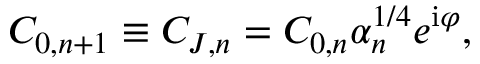<formula> <loc_0><loc_0><loc_500><loc_500>C _ { 0 , n + 1 } \equiv C _ { J , n } = C _ { 0 , n } \alpha _ { n } ^ { 1 / 4 } e ^ { i \varphi } ,</formula> 